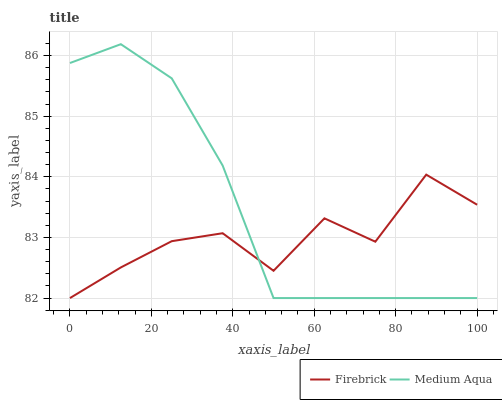Does Firebrick have the minimum area under the curve?
Answer yes or no. Yes. Does Medium Aqua have the maximum area under the curve?
Answer yes or no. Yes. Does Medium Aqua have the minimum area under the curve?
Answer yes or no. No. Is Medium Aqua the smoothest?
Answer yes or no. Yes. Is Firebrick the roughest?
Answer yes or no. Yes. Is Medium Aqua the roughest?
Answer yes or no. No. 